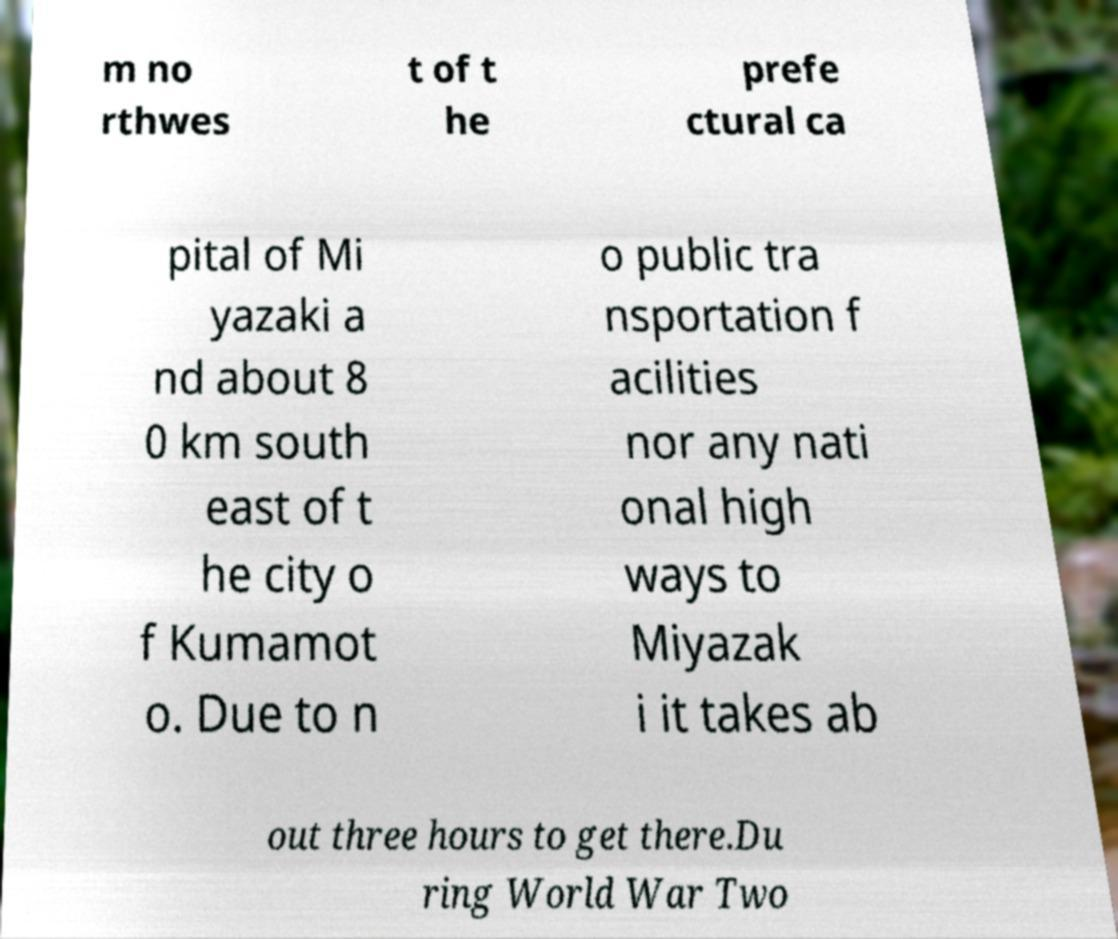Can you read and provide the text displayed in the image?This photo seems to have some interesting text. Can you extract and type it out for me? m no rthwes t of t he prefe ctural ca pital of Mi yazaki a nd about 8 0 km south east of t he city o f Kumamot o. Due to n o public tra nsportation f acilities nor any nati onal high ways to Miyazak i it takes ab out three hours to get there.Du ring World War Two 